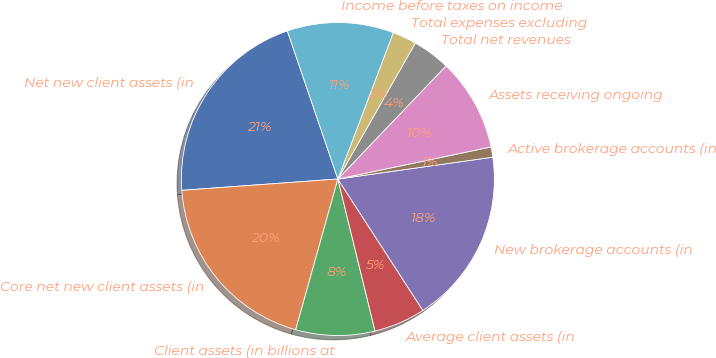Convert chart to OTSL. <chart><loc_0><loc_0><loc_500><loc_500><pie_chart><fcel>Net new client assets (in<fcel>Core net new client assets (in<fcel>Client assets (in billions at<fcel>Average client assets (in<fcel>New brokerage accounts (in<fcel>Active brokerage accounts (in<fcel>Assets receiving ongoing<fcel>Total net revenues<fcel>Total expenses excluding<fcel>Income before taxes on income<nl><fcel>20.92%<fcel>19.5%<fcel>8.16%<fcel>5.32%<fcel>18.09%<fcel>1.06%<fcel>9.57%<fcel>3.9%<fcel>2.48%<fcel>10.99%<nl></chart> 